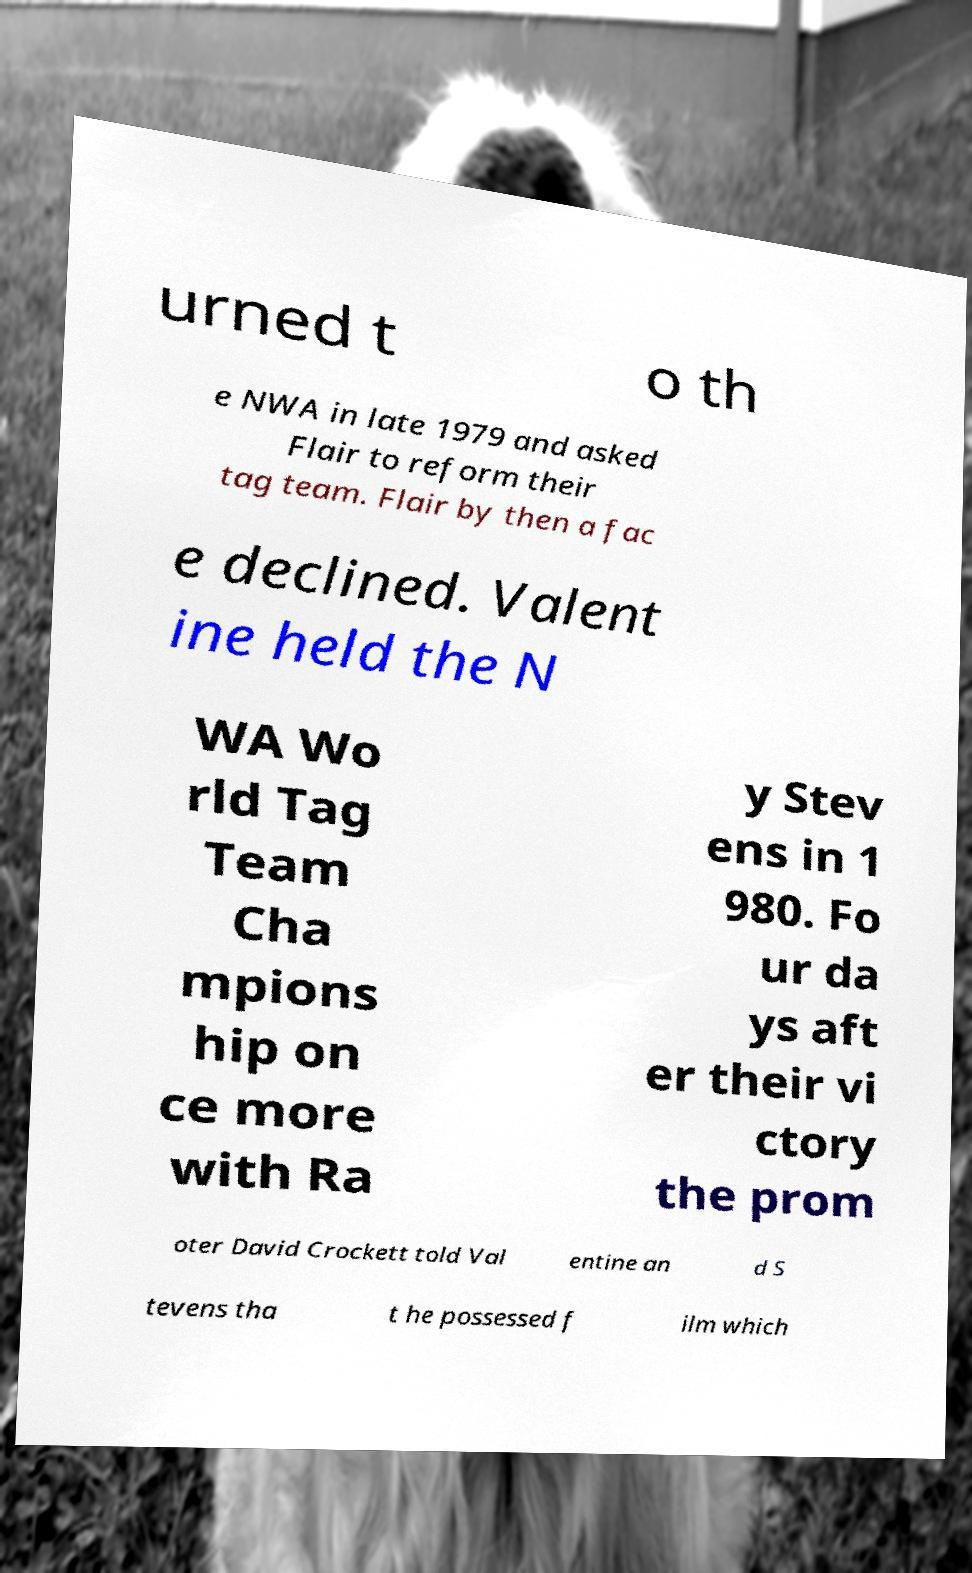Could you extract and type out the text from this image? urned t o th e NWA in late 1979 and asked Flair to reform their tag team. Flair by then a fac e declined. Valent ine held the N WA Wo rld Tag Team Cha mpions hip on ce more with Ra y Stev ens in 1 980. Fo ur da ys aft er their vi ctory the prom oter David Crockett told Val entine an d S tevens tha t he possessed f ilm which 